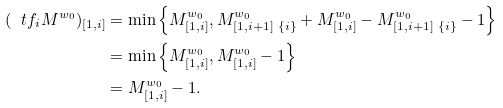<formula> <loc_0><loc_0><loc_500><loc_500>( \ t f _ { i } { M } ^ { w _ { 0 } } ) _ { [ 1 , i ] } & = \min \left \{ M ^ { w _ { 0 } } _ { [ 1 , i ] } , M ^ { w _ { 0 } } _ { [ 1 , i + 1 ] \ \{ i \} } + M _ { [ 1 , i ] } ^ { w _ { 0 } } - M ^ { w _ { 0 } } _ { [ 1 , i + 1 ] \ \{ i \} } - 1 \right \} \\ & = \min \left \{ M ^ { w _ { 0 } } _ { [ 1 , i ] } , M ^ { w _ { 0 } } _ { [ 1 , i ] } - 1 \right \} \\ & = M ^ { w _ { 0 } } _ { [ 1 , i ] } - 1 .</formula> 